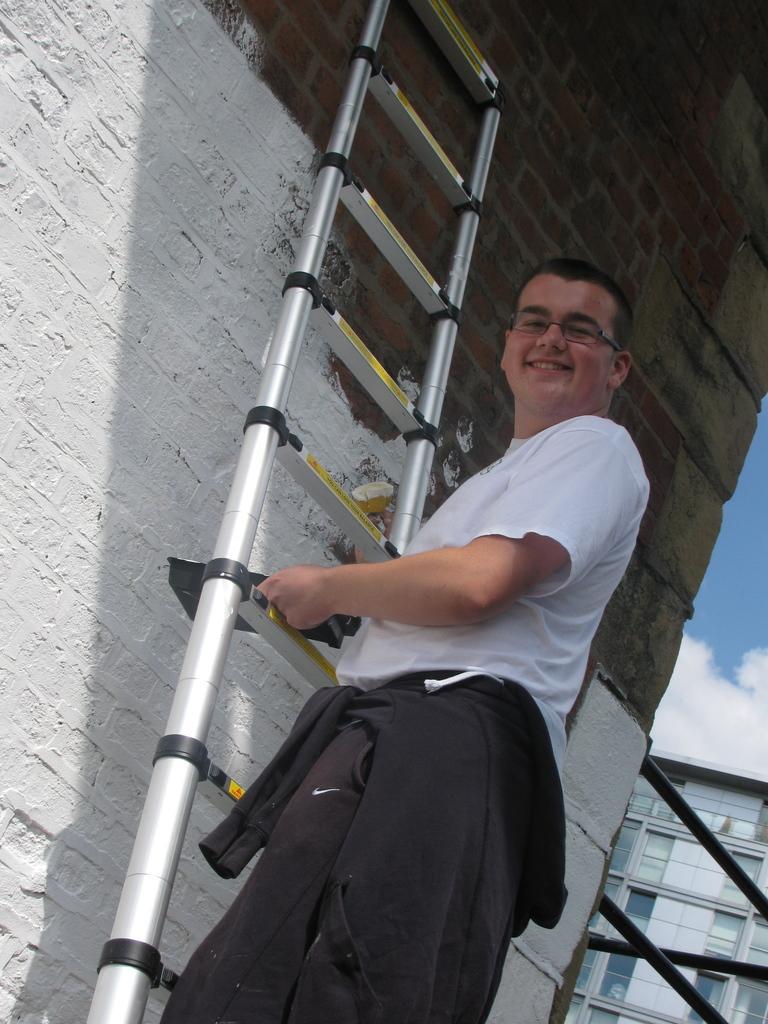Can you describe this image briefly? In this image there is a person climbing ladder on the building, beside that there is another building. 